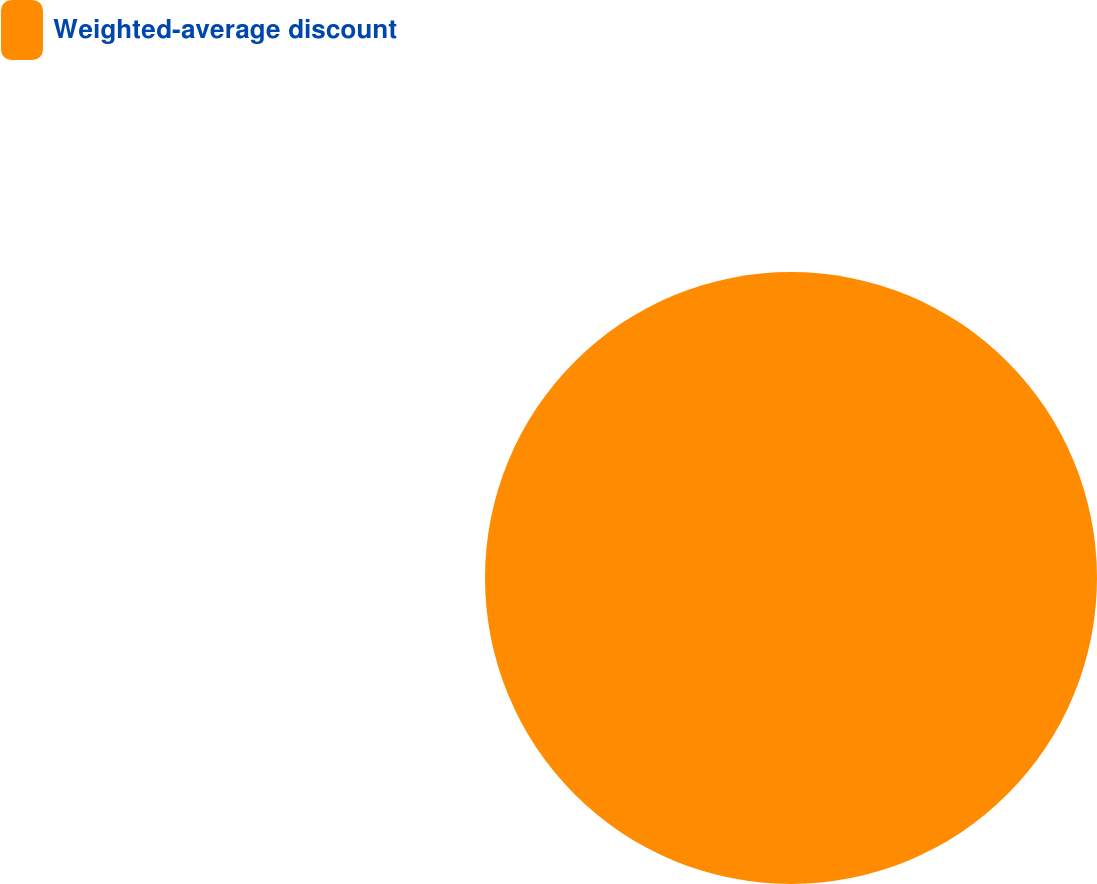Convert chart to OTSL. <chart><loc_0><loc_0><loc_500><loc_500><pie_chart><fcel>Weighted-average discount<nl><fcel>100.0%<nl></chart> 